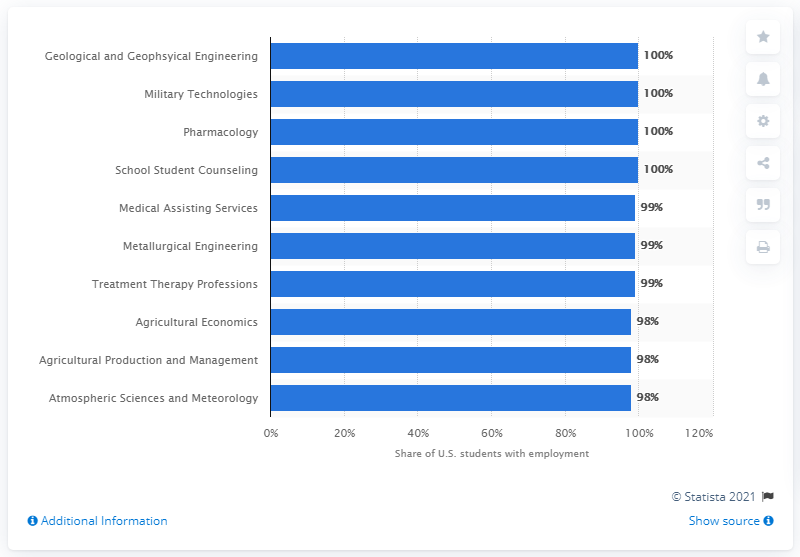Give some essential details in this illustration. According to data, 100% of geological and geophysical engineering students who graduated from their respective programs were employed within the field after completing their degree. 